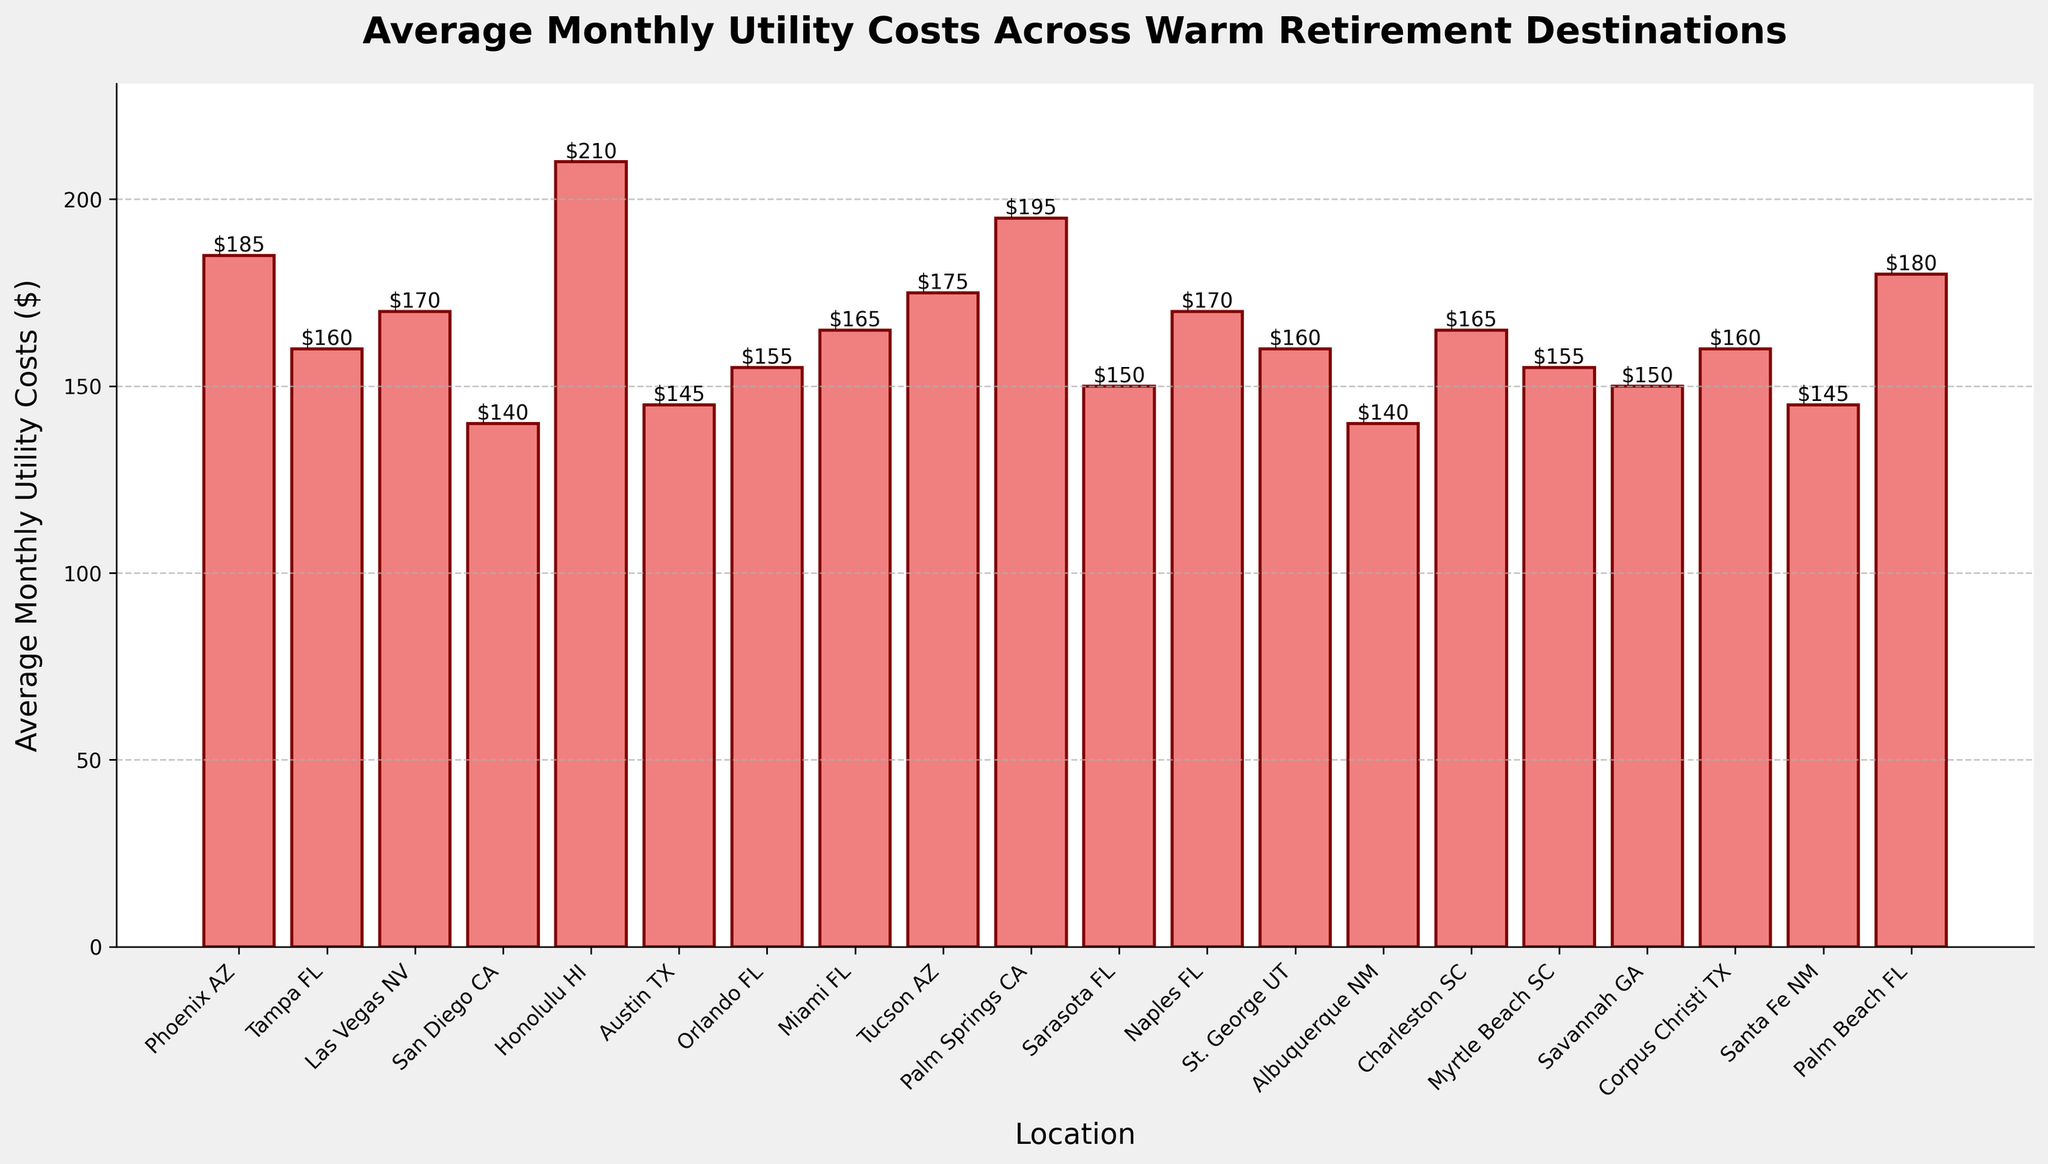Which location has the highest average monthly utility costs? The highest bar represents the location with the highest average monthly utility costs. In the figure, Honolulu HI has the highest bar.
Answer: Honolulu HI Which location has the lowest average monthly utility costs? The lowest bar represents the location with the lowest average monthly utility costs. In the figure, both San Diego CA and Albuquerque NM have the lowest bars.
Answer: San Diego CA and Albuquerque NM Which state has the most cities listed in the chart? Counting the number of cities for each state: Florida (Tampa, Orlando, Miami, Sarasota, Naples, Palm Beach) has 6 cities.
Answer: Florida How much higher are the average monthly utility costs in Honolulu HI compared to Miami FL? Subtract the average monthly utility costs of Miami FL ($165) from Honolulu HI ($210): $210 - $165 = $45.
Answer: $45 What is the difference in average monthly utility costs between Phoenix AZ and Tucson AZ? Subtract the average monthly utility costs of Tucson AZ ($175) from Phoenix AZ ($185): $185 - $175 = $10.
Answer: $10 What is the combined average monthly utility cost for the three cities with the lowest costs? San Diego CA ($140), Albuquerque NM ($140), and Santa Fe NM ($145). Sum these values: $140 + $140 + $145 = $425.
Answer: $425 Are the average monthly utility costs for any two cities exactly the same? Comparing the heights of the bars, Tampa FL, St. George UT, Corpus Christi TX, and Palm Beach FL all have average costs of $160. Additionally, Las Vegas NV and Naples FL both have average costs of $170.
Answer: Yes Which location in California has higher average monthly utility costs, Palm Springs CA or San Diego CA? Compare the heights of the bars for Palm Springs CA ($195) and San Diego CA ($140): Palm Springs CA has higher costs.
Answer: Palm Springs CA What are the average monthly utility costs for all Texas locations combined, and what is their average? Austin TX ($145) + Corpus Christi TX ($160) = $305. There are 2 locations. Calculate the average: $305 / 2 = $152.50.
Answer: $152.50 What is the difference in average monthly utility costs between the highest and lowest cost locations? Subtract the lowest average cost (San Diego CA and Albuquerque NM, both $140) from the highest (Honolulu HI, $210): $210 - $140 = $70.
Answer: $70 